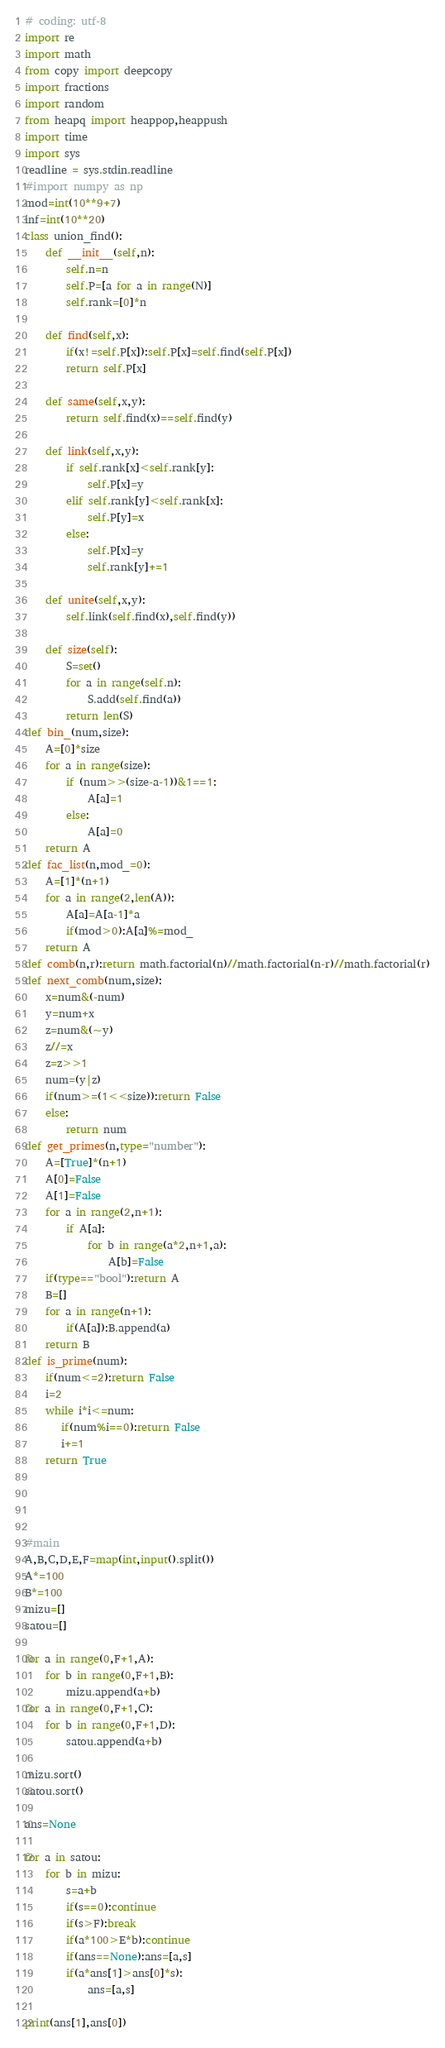Convert code to text. <code><loc_0><loc_0><loc_500><loc_500><_Python_># coding: utf-8
import re
import math
from copy import deepcopy
import fractions
import random
from heapq import heappop,heappush
import time
import sys
readline = sys.stdin.readline
#import numpy as np
mod=int(10**9+7)
inf=int(10**20)
class union_find():
    def __init__(self,n):
        self.n=n
        self.P=[a for a in range(N)]
        self.rank=[0]*n
 
    def find(self,x):
        if(x!=self.P[x]):self.P[x]=self.find(self.P[x])
        return self.P[x]
 
    def same(self,x,y):
        return self.find(x)==self.find(y)
 
    def link(self,x,y):
        if self.rank[x]<self.rank[y]:
            self.P[x]=y
        elif self.rank[y]<self.rank[x]:
            self.P[y]=x
        else:
            self.P[x]=y
            self.rank[y]+=1
 
    def unite(self,x,y):
        self.link(self.find(x),self.find(y))
 
    def size(self):
        S=set()
        for a in range(self.n):
            S.add(self.find(a))
        return len(S)
def bin_(num,size):
    A=[0]*size
    for a in range(size):
        if (num>>(size-a-1))&1==1:
            A[a]=1
        else:
            A[a]=0
    return A
def fac_list(n,mod_=0):
    A=[1]*(n+1)
    for a in range(2,len(A)):
        A[a]=A[a-1]*a
        if(mod>0):A[a]%=mod_
    return A
def comb(n,r):return math.factorial(n)//math.factorial(n-r)//math.factorial(r)
def next_comb(num,size):
    x=num&(-num)
    y=num+x
    z=num&(~y)
    z//=x
    z=z>>1
    num=(y|z)
    if(num>=(1<<size)):return False
    else:
        return num
def get_primes(n,type="number"):
    A=[True]*(n+1)
    A[0]=False
    A[1]=False
    for a in range(2,n+1):
        if A[a]:
            for b in range(a*2,n+1,a):
                A[b]=False
    if(type=="bool"):return A
    B=[]
    for a in range(n+1):
        if(A[a]):B.append(a)
    return B
def is_prime(num):
    if(num<=2):return False
    i=2
    while i*i<=num:
       if(num%i==0):return False
       i+=1
    return True

 

 
#main
A,B,C,D,E,F=map(int,input().split())
A*=100
B*=100
mizu=[]
satou=[]

for a in range(0,F+1,A):
    for b in range(0,F+1,B):
        mizu.append(a+b)
for a in range(0,F+1,C):
    for b in range(0,F+1,D):
        satou.append(a+b)

mizu.sort()
satou.sort()

ans=None

for a in satou:
    for b in mizu:
        s=a+b
        if(s==0):continue
        if(s>F):break
        if(a*100>E*b):continue
        if(ans==None):ans=[a,s]
        if(a*ans[1]>ans[0]*s):
            ans=[a,s]

print(ans[1],ans[0])
</code> 